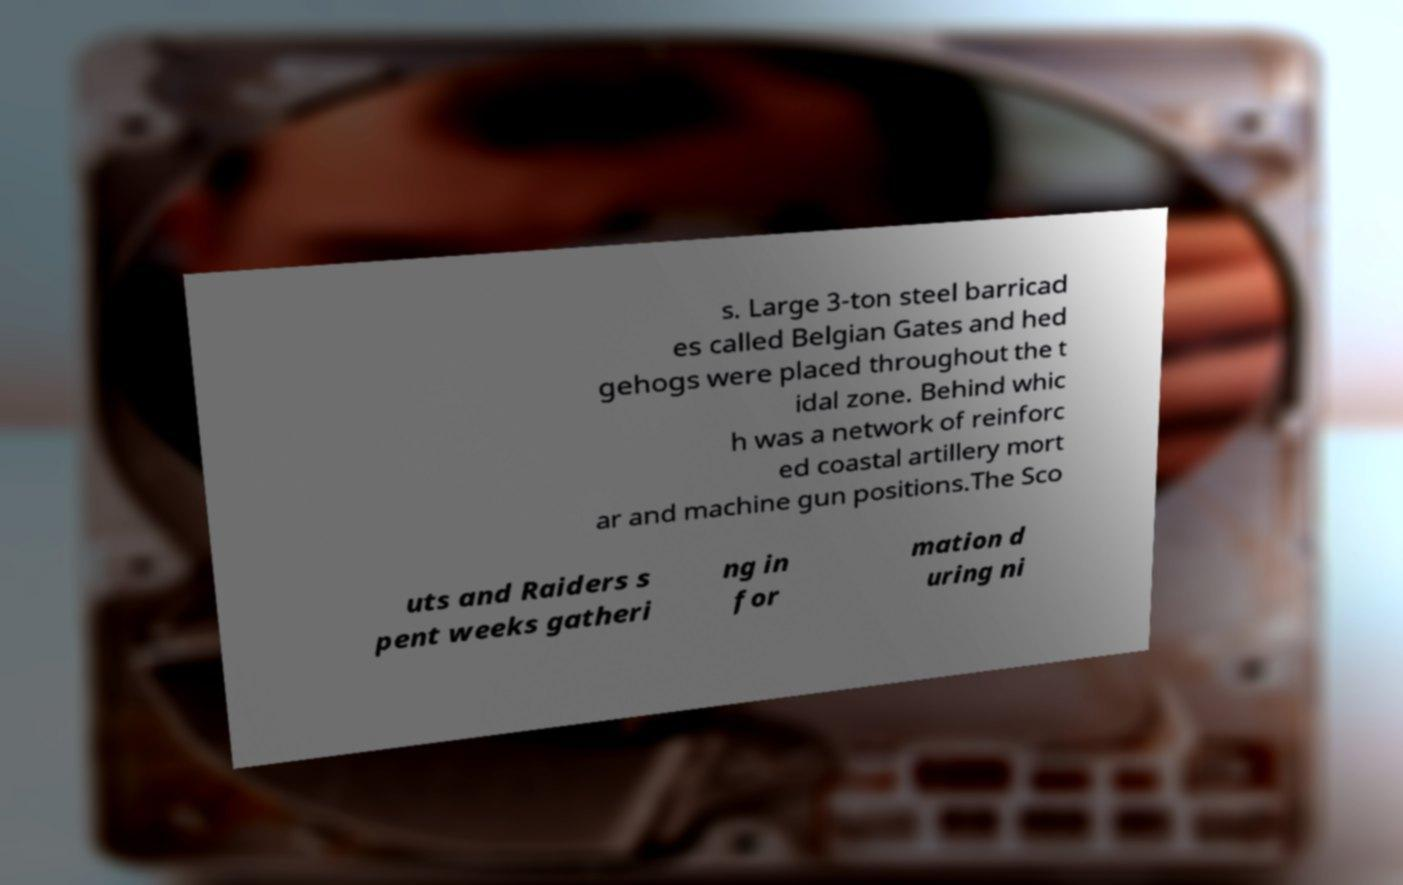For documentation purposes, I need the text within this image transcribed. Could you provide that? s. Large 3-ton steel barricad es called Belgian Gates and hed gehogs were placed throughout the t idal zone. Behind whic h was a network of reinforc ed coastal artillery mort ar and machine gun positions.The Sco uts and Raiders s pent weeks gatheri ng in for mation d uring ni 